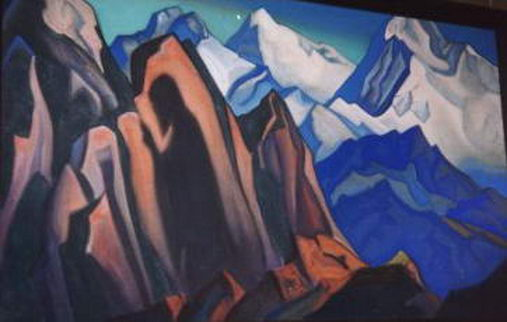Describe a day in the life of an artist painting this landscape on-site. A day in the life of an artist painting this cubist mountain landscape on-site begins in the early morning hours. As dawn breaks, the artist sets up their easel and materials at a carefully chosen vantage point, where the interplay of light and shadow is most dramatic. The crisp morning air fills their lungs as they take in the towering peaks and intricate rock formations. With each brushstroke, the artist captures the geometric essence of the scene, translating the mountain's rugged grandeur into abstract forms and angles. The cool morning hues gradually warm as the sun ascends, casting vivid contrasts and highlights that the artist deftly incorporates into the evolving masterpiece. Hours pass unnoticed as the artist immerses in their work, the rhythmic movements of their brush synchronized with the natural rhythm of the environment. By afternoon, the artist takes a break to absorb the scenery, finding new inspiration in every crevice and contour. As the day wanes, the artist continues to layer colors and shapes, the cubist style melding reality and abstraction into a cohesive and captivating tableau. The setting sun's warm glow infuses the final touches, and the artist steps back to survey the day's creation, a vibrant tribute to the powerful and serene beauty of the mountains. Create a short story inspired by this landscape that involves time travel. In the heart of the cubist mountain range, a hidden cave sheltered an ancient artifact known as the 'Chrono Crystal.' This crystal, shimmering with the colors of the landscape, had the power to traverse time. One day, a curious traveler stumbled upon the cave and, drawn by the crystal's allure, touched its surface. In an instant, the traveler was transported back thousands of years to an era when the mountains were revered as sacred grounds. They witnessed ancient tribes performing rituals, drawing strength and wisdom from the geometric peaks. Time passed in a blur as the traveler moved forward, seeing the rise of civilizations, the changes in the landscape, and the enduring presence of the mountains. The traveler learned the stories etched into the rocks, each crack and crevice a testament to the passage of time. Finally, the Chrono Crystal brought the traveler back to the present, now imbued with a deep appreciation for the timelessness and resilience of the natural world. The experience forever changed their perspective, and they decided to share the mountains' stories through art, capturing the essence of their journey in a series of cubist paintings that spoke of time, change, and the enduring spirit of nature. 